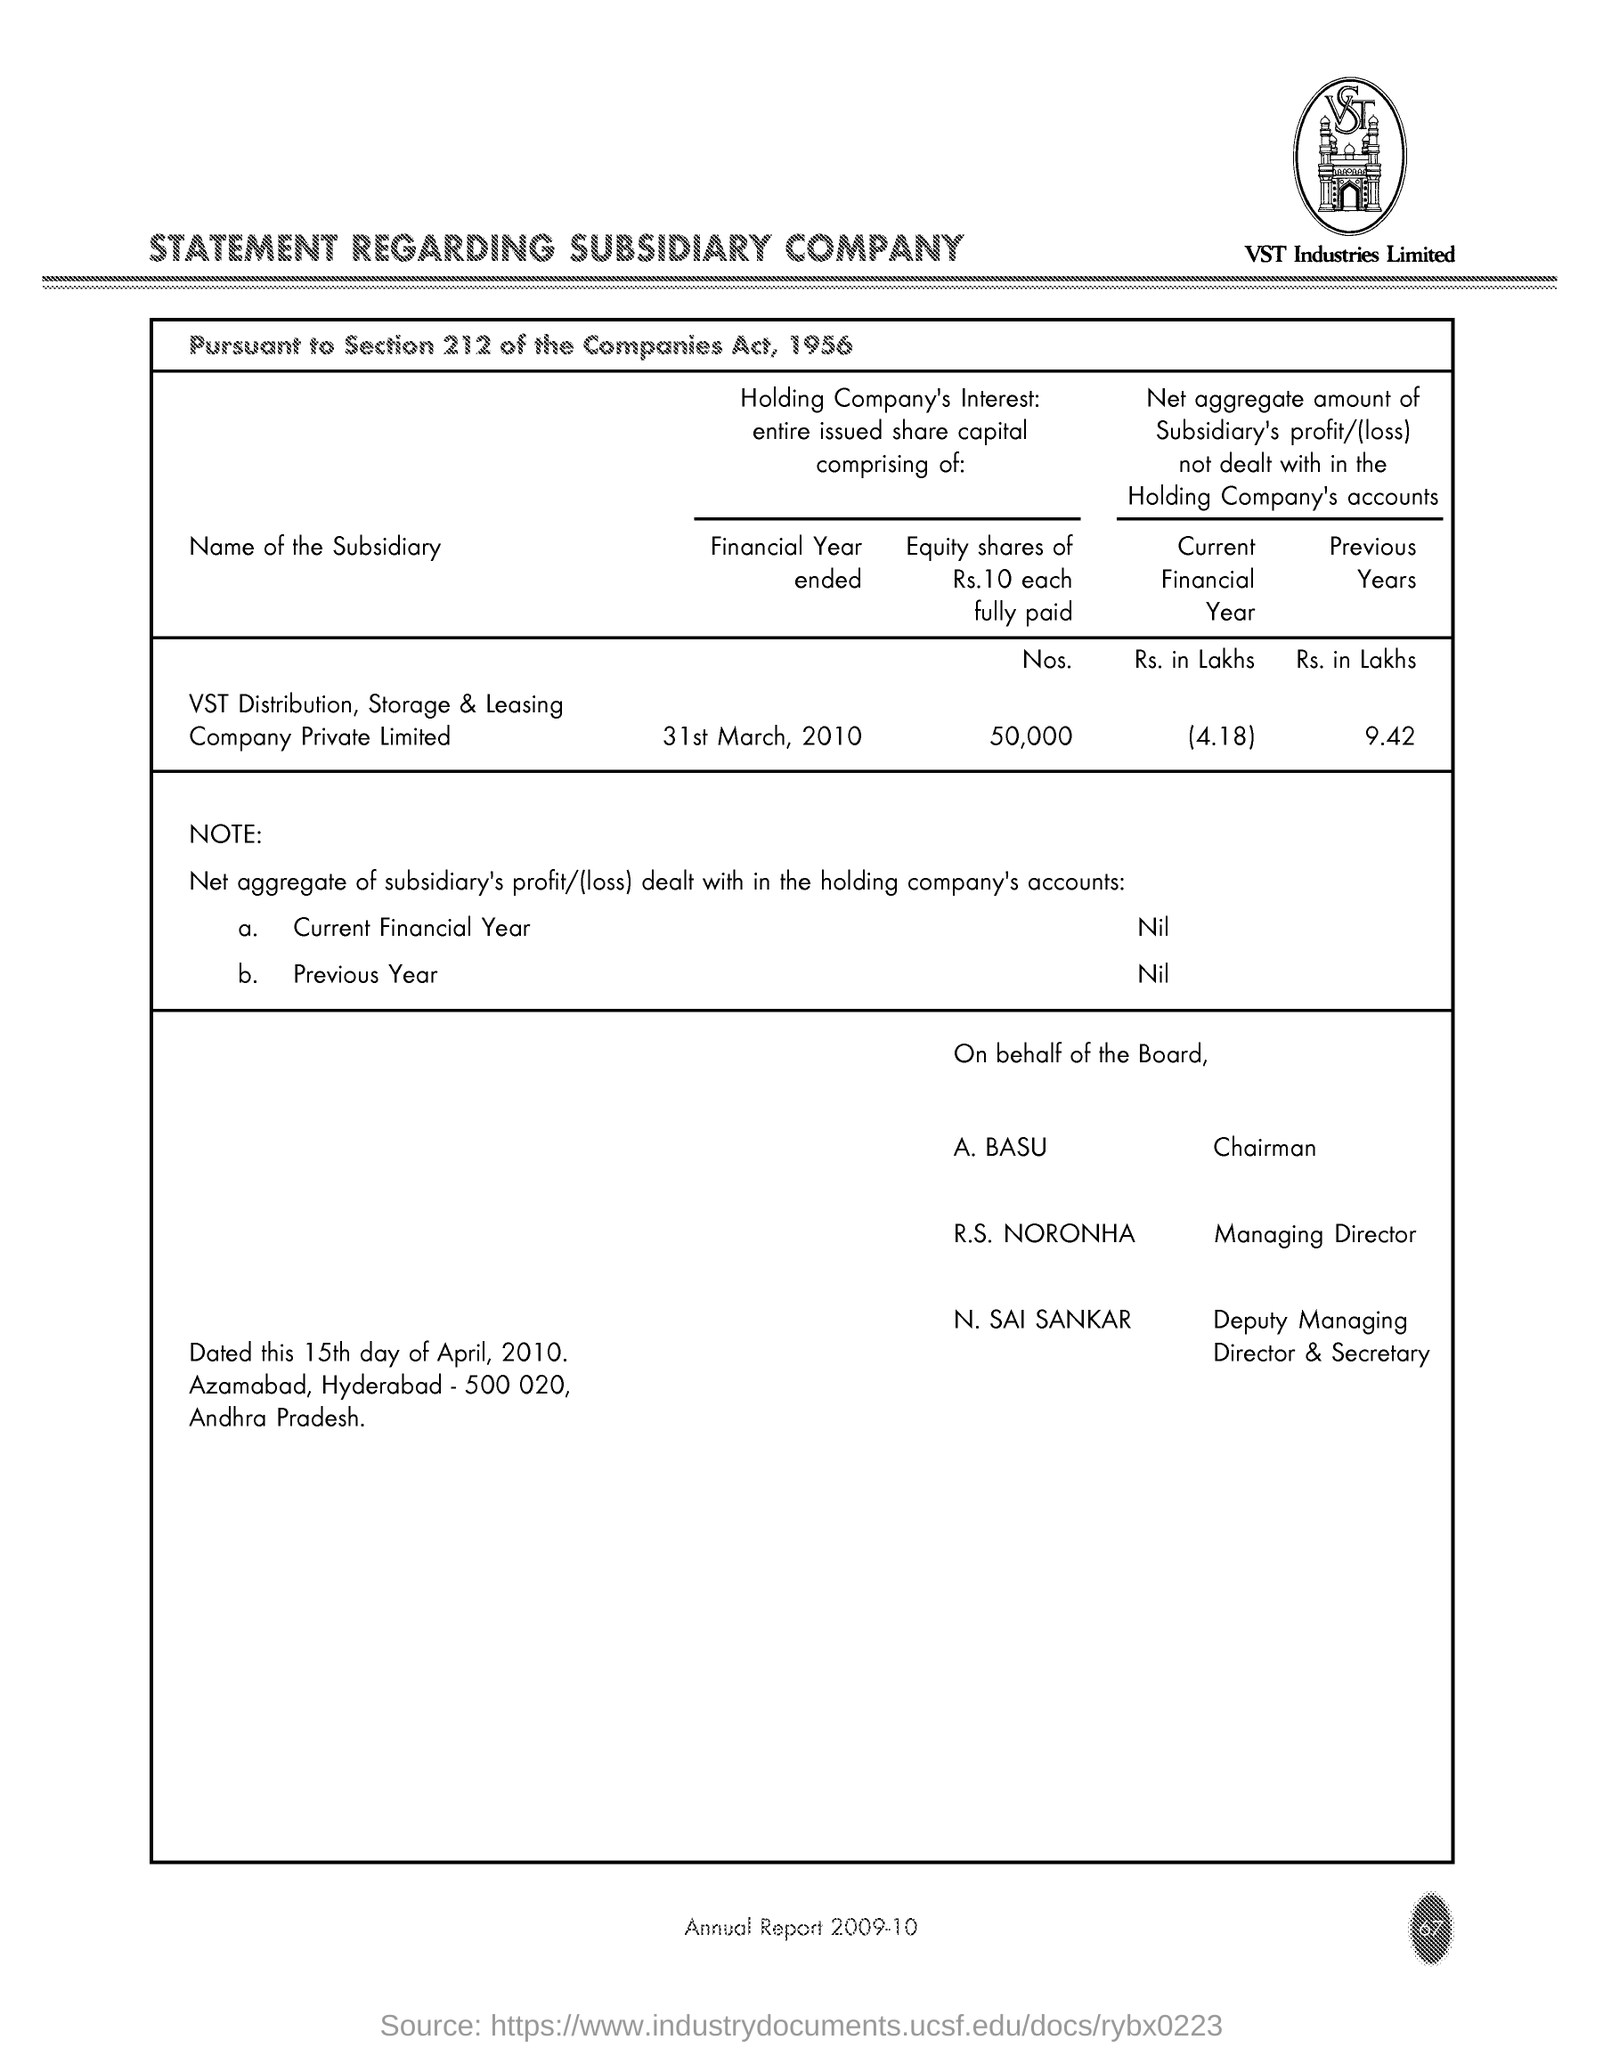What is the Net aggregrate amount(Rs. in lakhs) of Subsidiary's profit/(loss) not dealt within the Holding Company's accounts in the current financial year?
Provide a short and direct response. (4.18). What is the Net aggregrate amount(Rs. in lakhs) of Subsidiary's profit/(loss) not dealt within the Holding Company's accounts in the previous years?
Your answer should be compact. 9.42. What is the No of Equity share of Rs.10 each fully paid?
Your response must be concise. 50,000. When is the financial year ended as per the statement?
Make the answer very short. 31st March, 2010. What is the Net aggregrate amount of Subsidiary's profit/(loss) dealt within the Holding Company's accounts in the current financial year?
Keep it short and to the point. Nil. Who is R.S. NORONHA?
Ensure brevity in your answer.  Managing Director. What type of statement is given here?
Provide a short and direct response. STATEMENT REGARDING SUBSIDIARY COMPANY. 